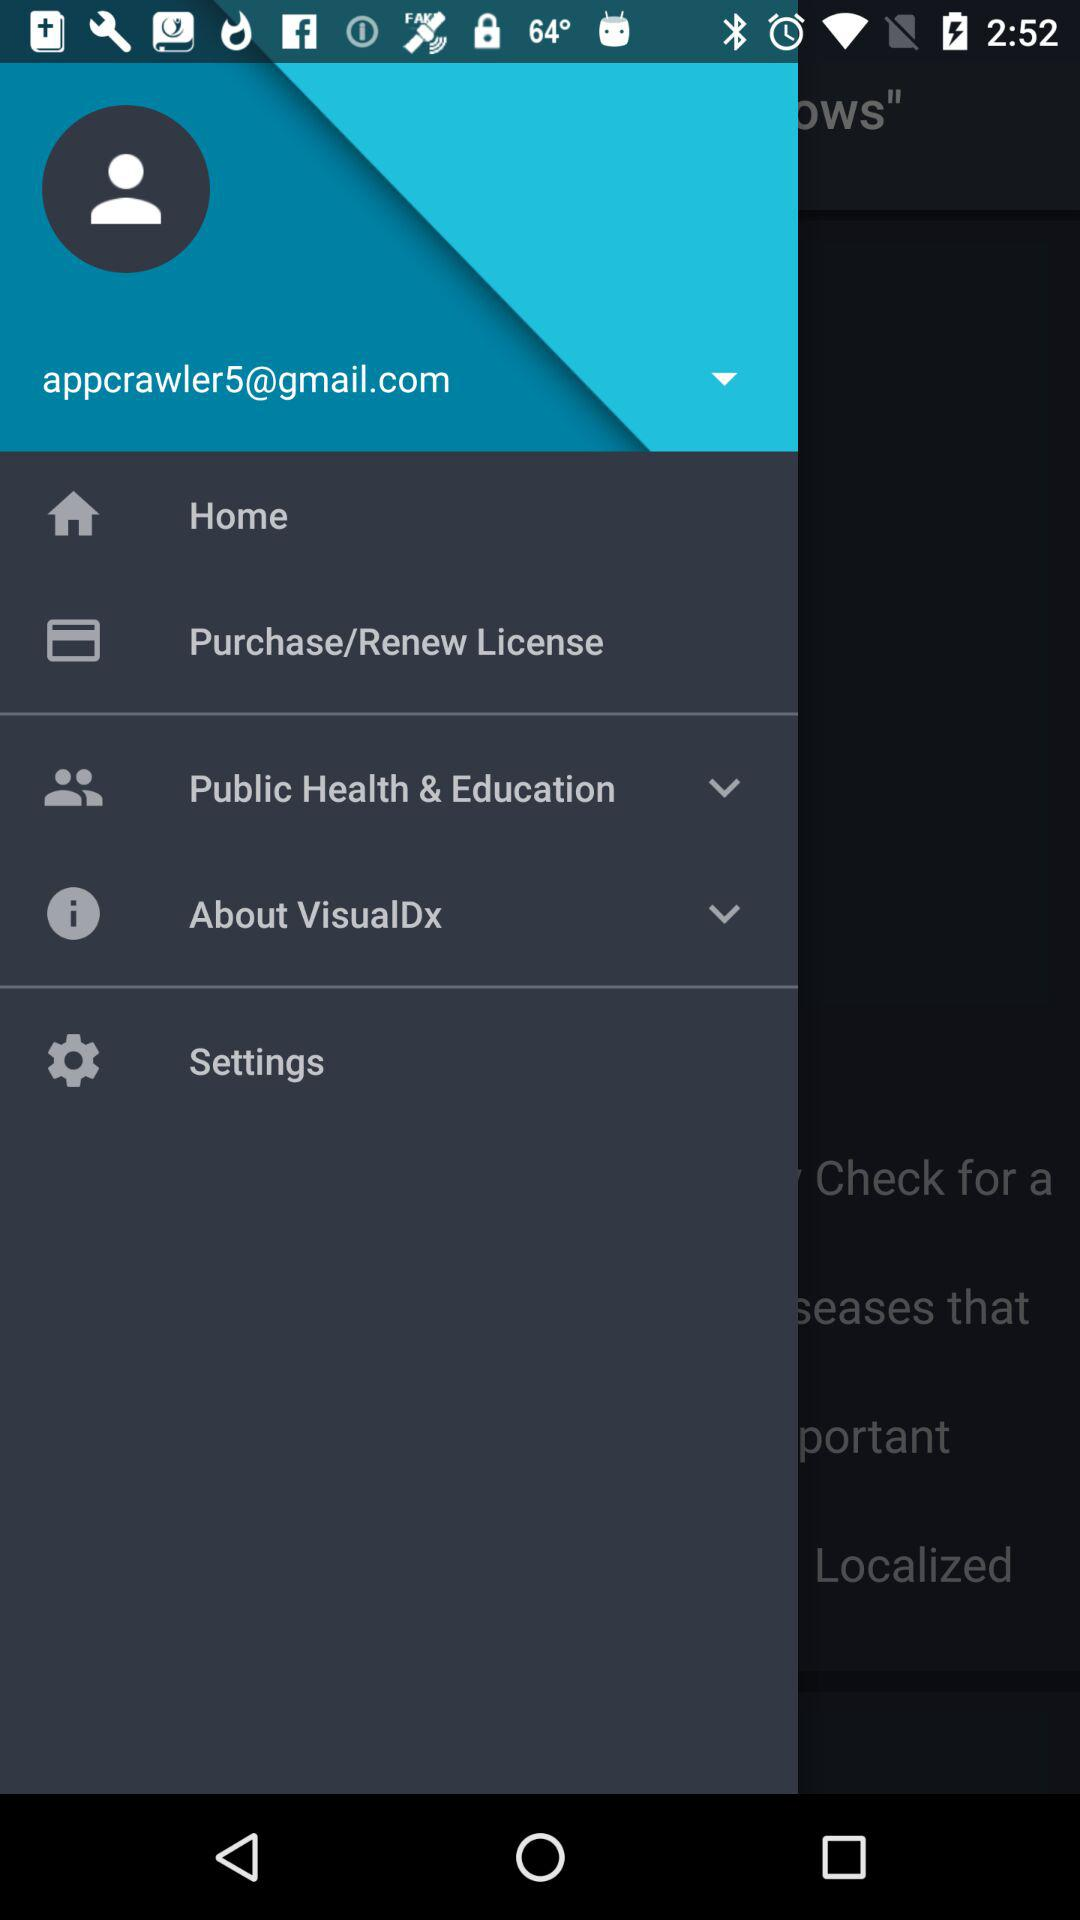What is the email address? The email address is appcrawler5@gmail.com. 